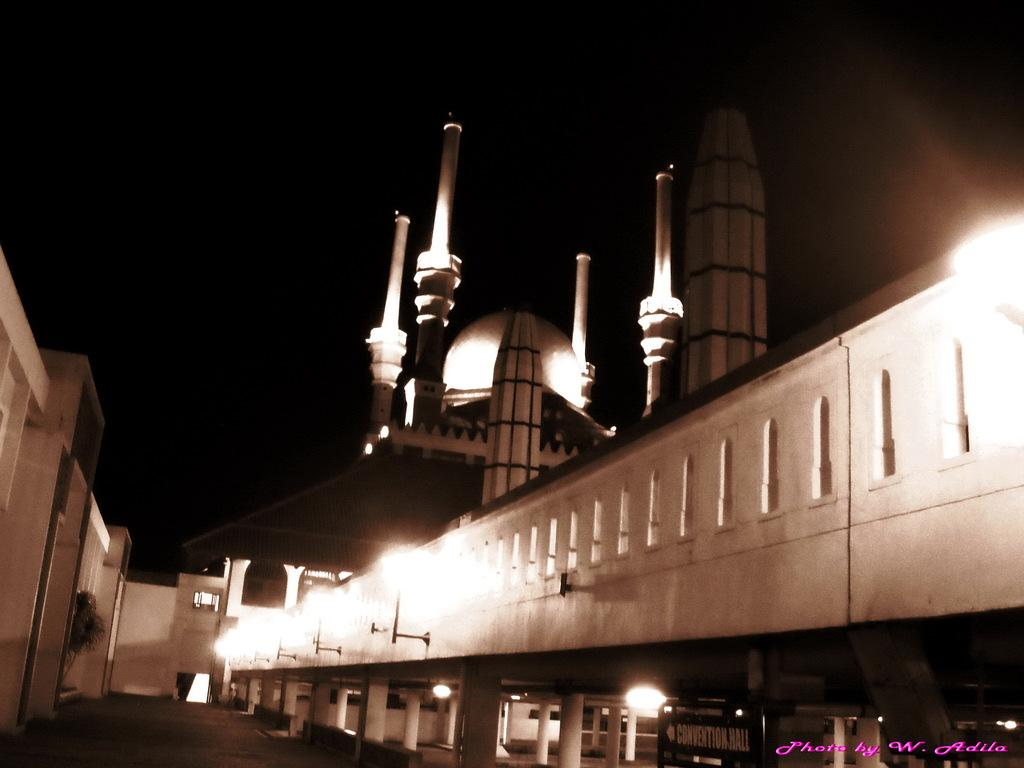What type of structure can be seen in the image? There is a wall, lights, pillars, a board, poles, and a dome in the image. What architectural features are present in the image? The image features pillars and a dome. What is written or displayed on the board in the image? The content of the board cannot be determined from the image. What is the color of the background in the image? The background of the image is dark. Is there any text visible in the image? Yes, there is text in the bottom right side of the image. What type of sofa can be seen in the image? There is no sofa present in the image. How many trees are visible in the image? There are no trees visible in the image. 